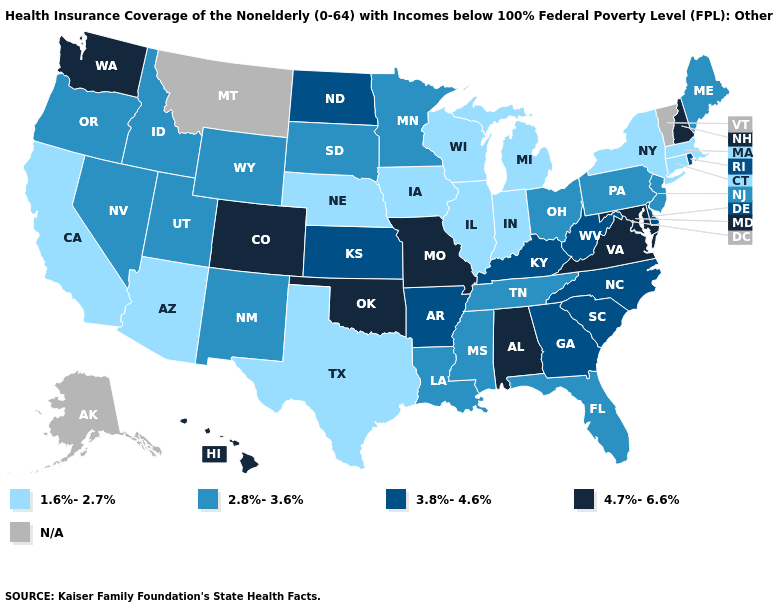What is the highest value in states that border New Hampshire?
Keep it brief. 2.8%-3.6%. What is the value of Rhode Island?
Concise answer only. 3.8%-4.6%. What is the value of Minnesota?
Answer briefly. 2.8%-3.6%. Name the states that have a value in the range 1.6%-2.7%?
Be succinct. Arizona, California, Connecticut, Illinois, Indiana, Iowa, Massachusetts, Michigan, Nebraska, New York, Texas, Wisconsin. Does the map have missing data?
Concise answer only. Yes. What is the highest value in the USA?
Short answer required. 4.7%-6.6%. What is the value of North Carolina?
Give a very brief answer. 3.8%-4.6%. What is the value of Michigan?
Quick response, please. 1.6%-2.7%. Does Iowa have the lowest value in the MidWest?
Answer briefly. Yes. Does Maine have the highest value in the USA?
Short answer required. No. Which states have the lowest value in the USA?
Concise answer only. Arizona, California, Connecticut, Illinois, Indiana, Iowa, Massachusetts, Michigan, Nebraska, New York, Texas, Wisconsin. Does West Virginia have the lowest value in the USA?
Answer briefly. No. Name the states that have a value in the range 2.8%-3.6%?
Answer briefly. Florida, Idaho, Louisiana, Maine, Minnesota, Mississippi, Nevada, New Jersey, New Mexico, Ohio, Oregon, Pennsylvania, South Dakota, Tennessee, Utah, Wyoming. What is the lowest value in the USA?
Answer briefly. 1.6%-2.7%. 